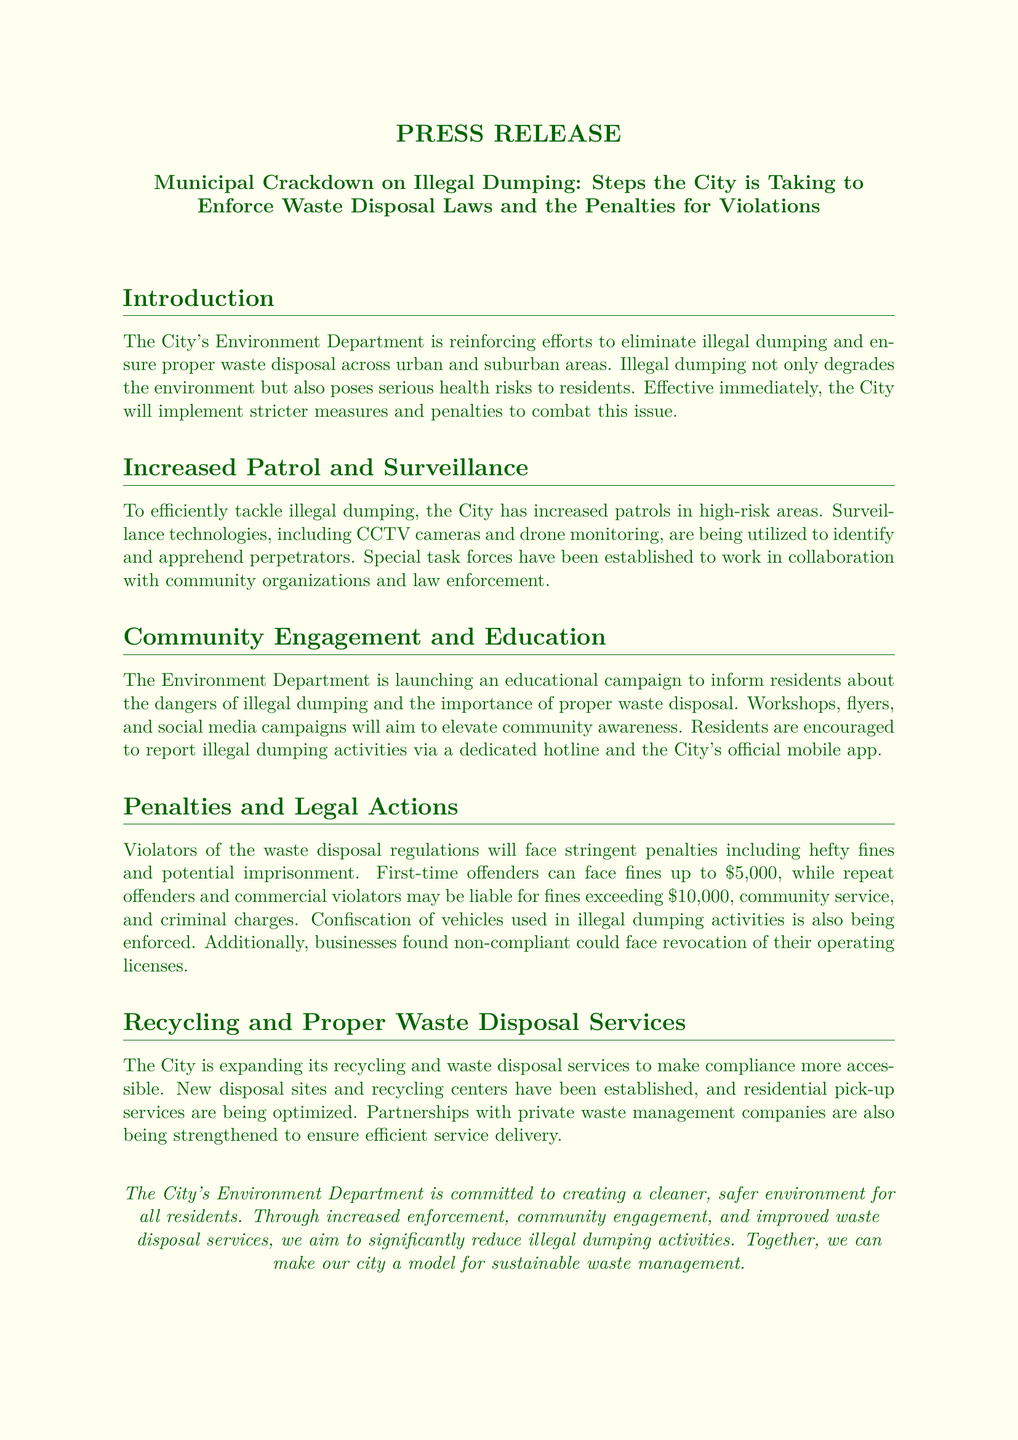What is the title of the press release? The title is explicitly stated at the beginning of the document, detailing the subject matter.
Answer: Municipal Crackdown on Illegal Dumping: Steps the City is Taking to Enforce Waste Disposal Laws and the Penalties for Violations What is the fine for first-time offenders? The document specifies the penalties that first-time offenders face, which are presented clearly in the penalties section.
Answer: up to $5,000 What technologies are being used for surveillance? The document lists specific technologies that are being utilized to combat illegal dumping, providing insight into the enforcement strategies.
Answer: CCTV cameras and drone monitoring What community engagement methods will be employed? The press release outlines the initiatives the Environment Department will undertake to engage with the community, reflecting their strategies for education.
Answer: Workshops, flyers, and social media campaigns What is the penalty for repeat offenders? The document describes the consequences for repeat offenders, which are distinct from those of first-time offenders.
Answer: fines exceeding $10,000, community service, and criminal charges How is the City improving waste disposal services? The document describes the expansion of services related to recycling and waste disposal, focusing on accessibility and compliance.
Answer: New disposal sites and recycling centers What hotline should residents use to report illegal dumping? The document mentions a dedicated hotline for residents to report illegal activities, which serves as a communication tool.
Answer: dedicated hotline Who is the contact person for more information? The press release provides contact details for inquiries, indicating the spokesperson for the Environment Department.
Answer: John Doe 